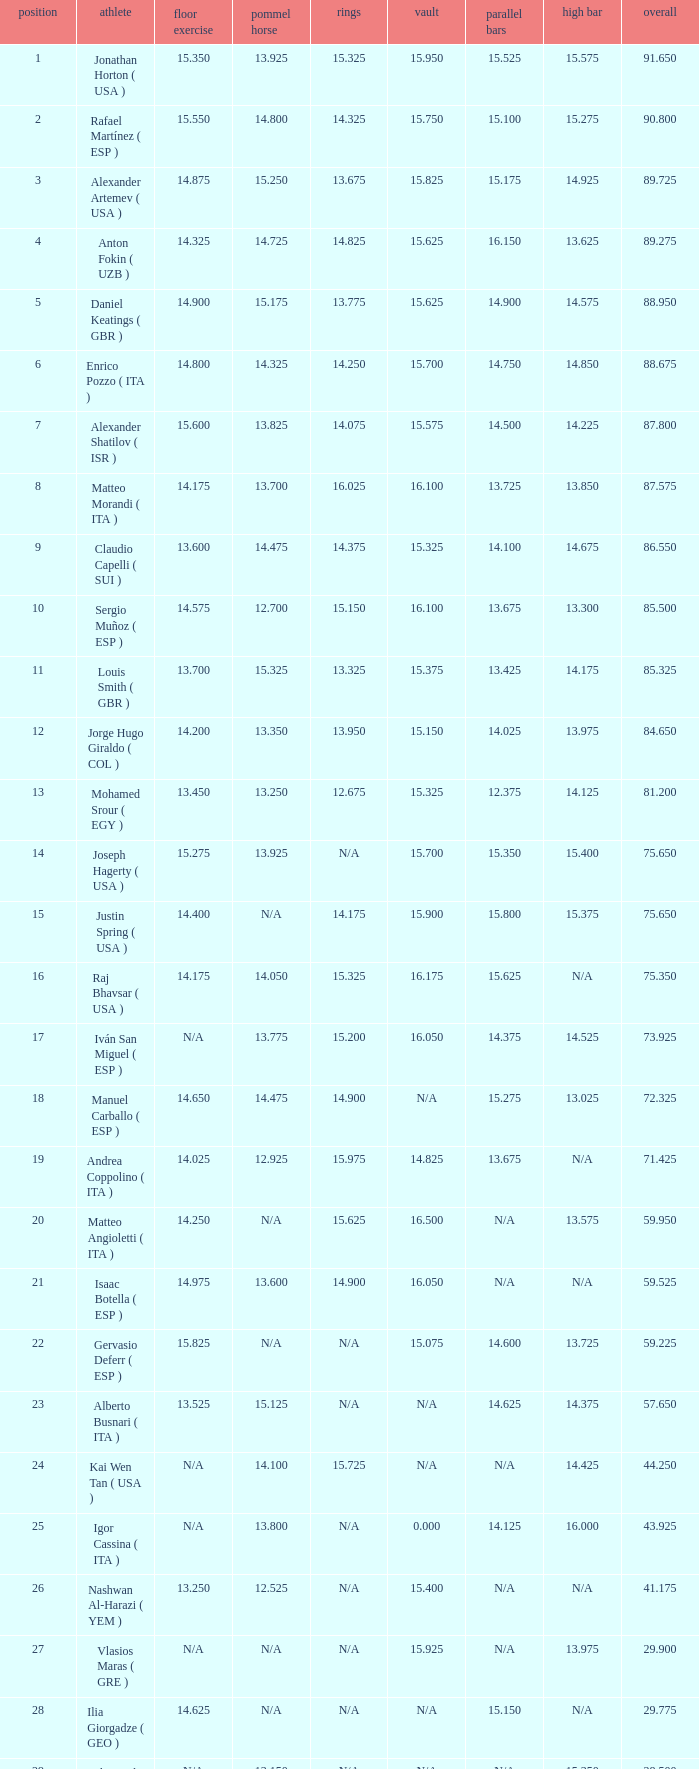If the horizontal bar is n/a and the floor is 14.175, what is the number for the parallel bars? 15.625. 